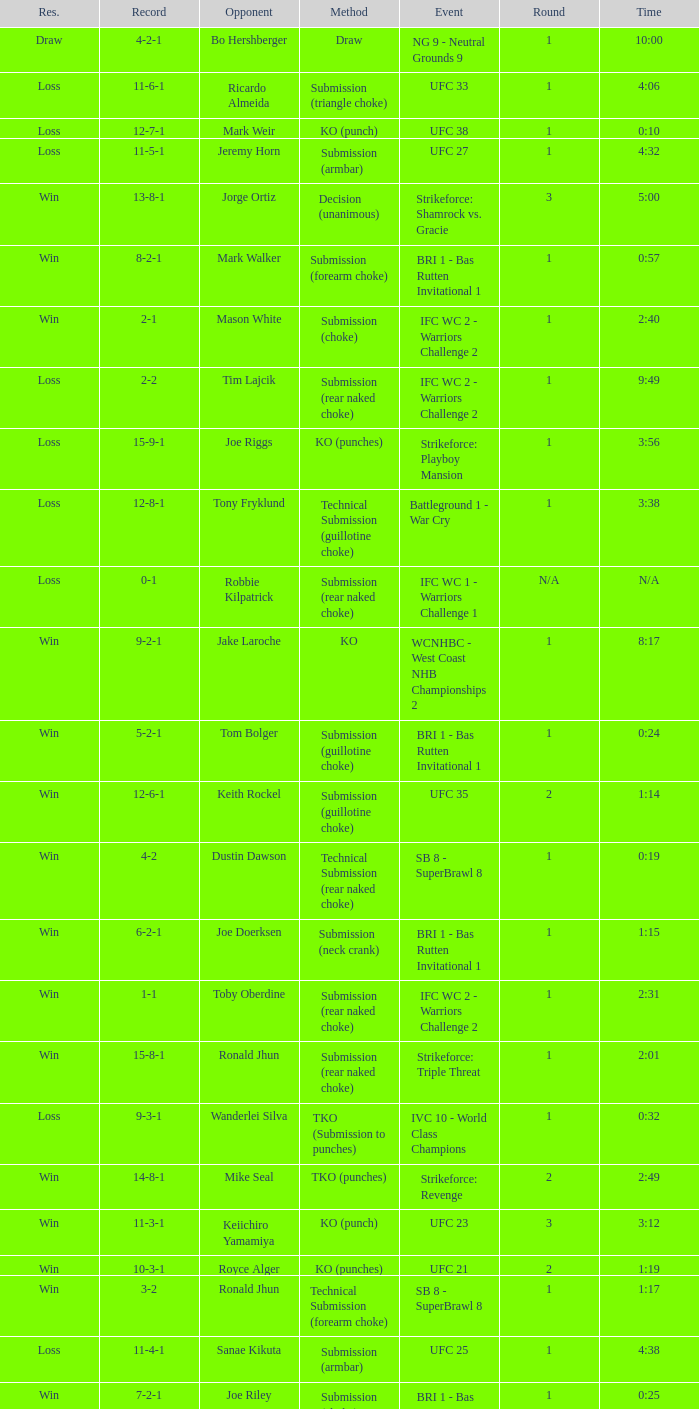What was the resolution for the fight against tom bolger by submission (guillotine choke)? Win. 